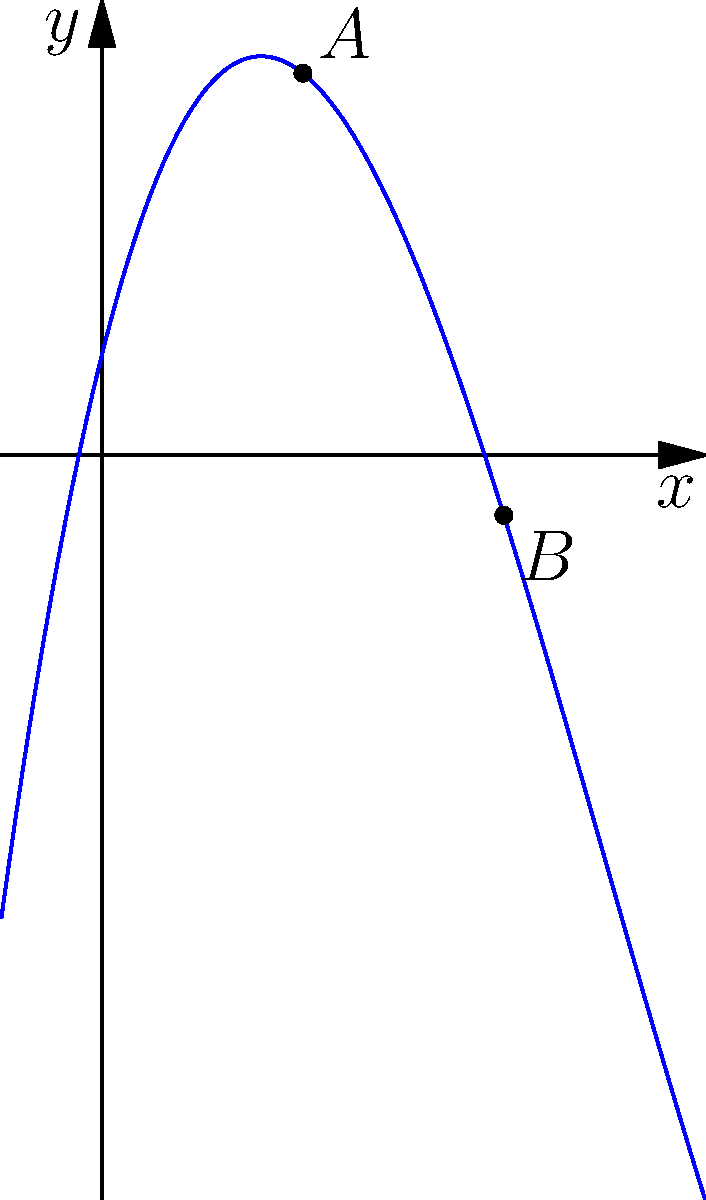Given the graph of a polynomial function $f(x)$, determine the intervals where the function is increasing and decreasing. Points $A$ and $B$ are local extrema of the function. To determine the intervals where the function is increasing or decreasing, we need to analyze the graph from left to right:

1. Identify the x-coordinates of the local extrema:
   Point $A$ is at $x \approx 2$
   Point $B$ is at $x \approx 4$

2. Divide the x-axis into intervals based on these points:
   $(-\infty, 2)$, $(2, 4)$, and $(4, \infty)$

3. Analyze each interval:
   a) $(-\infty, 2)$: The graph is rising, so $f(x)$ is increasing
   b) $(2, 4)$: The graph is falling, so $f(x)$ is decreasing
   c) $(4, \infty)$: The graph is rising, so $f(x)$ is increasing

4. Translate the intervals into mathematical notation:
   Increasing: $x \in (-\infty, 2) \cup (4, \infty)$
   Decreasing: $x \in (2, 4)$

As a translator, it's important to express these mathematical concepts accurately in multiple languages, maintaining the precise meaning of the intervals and mathematical notations.
Answer: Increasing: $x \in (-\infty, 2) \cup (4, \infty)$; Decreasing: $x \in (2, 4)$ 